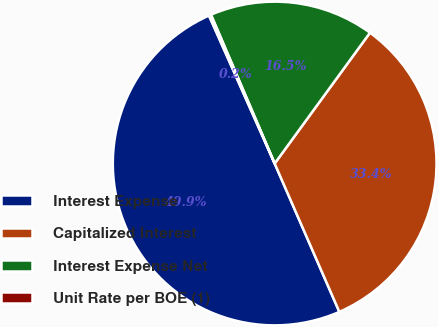Convert chart. <chart><loc_0><loc_0><loc_500><loc_500><pie_chart><fcel>Interest Expense<fcel>Capitalized Interest<fcel>Interest Expense Net<fcel>Unit Rate per BOE (1)<nl><fcel>49.89%<fcel>33.43%<fcel>16.46%<fcel>0.21%<nl></chart> 